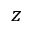Convert formula to latex. <formula><loc_0><loc_0><loc_500><loc_500>z</formula> 